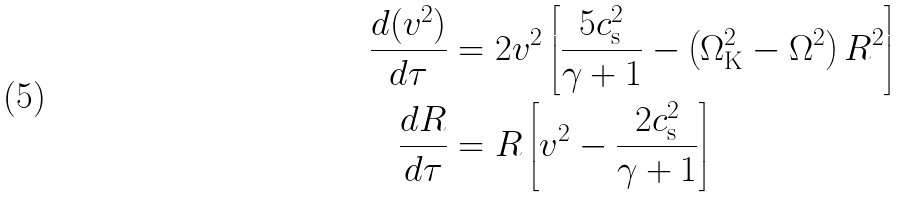Convert formula to latex. <formula><loc_0><loc_0><loc_500><loc_500>\frac { d ( v ^ { 2 } ) } { d \tau } & = 2 v ^ { 2 } \left [ \frac { 5 c _ { \mathrm s } ^ { 2 } } { \gamma + 1 } - \left ( \Omega _ { \mathrm K } ^ { 2 } - \Omega ^ { 2 } \right ) R ^ { 2 } \right ] \\ \frac { d R } { d \tau } & = R \left [ v ^ { 2 } - \frac { 2 c _ { \mathrm s } ^ { 2 } } { \gamma + 1 } \right ]</formula> 